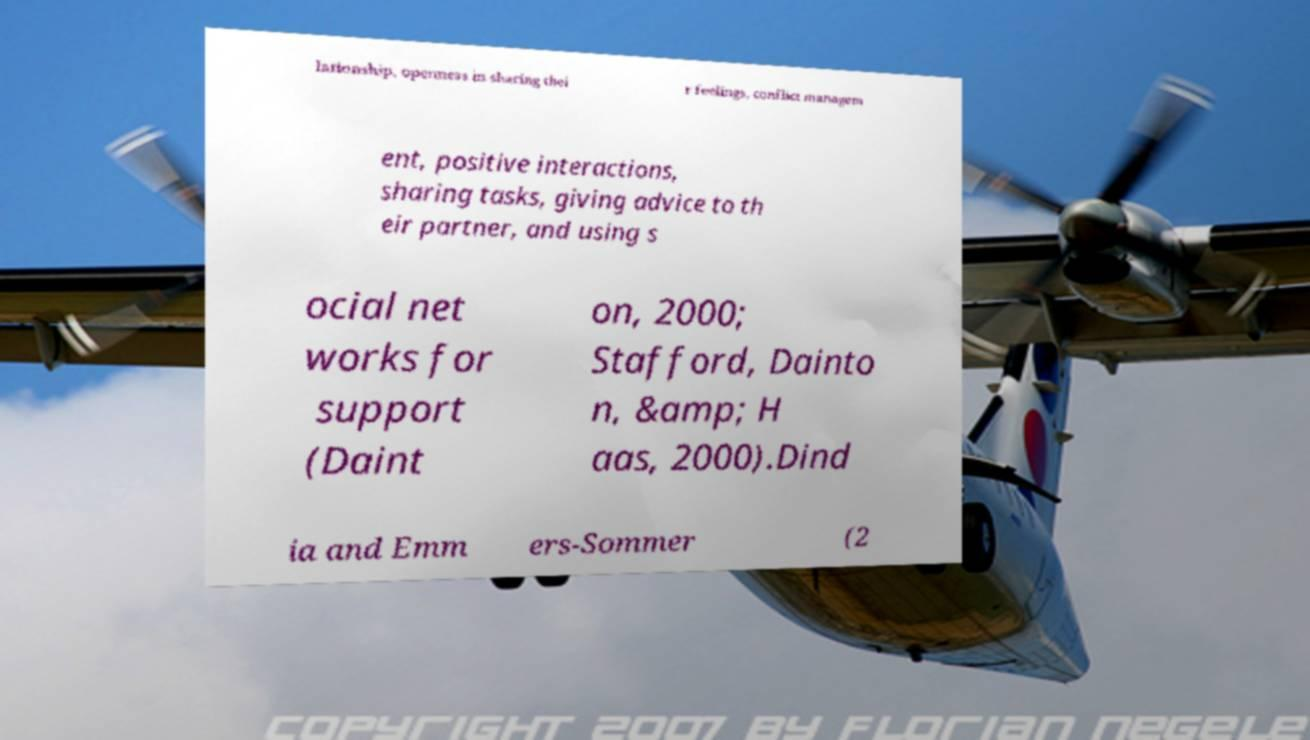Can you accurately transcribe the text from the provided image for me? lationship, openness in sharing thei r feelings, conflict managem ent, positive interactions, sharing tasks, giving advice to th eir partner, and using s ocial net works for support (Daint on, 2000; Stafford, Dainto n, &amp; H aas, 2000).Dind ia and Emm ers-Sommer (2 